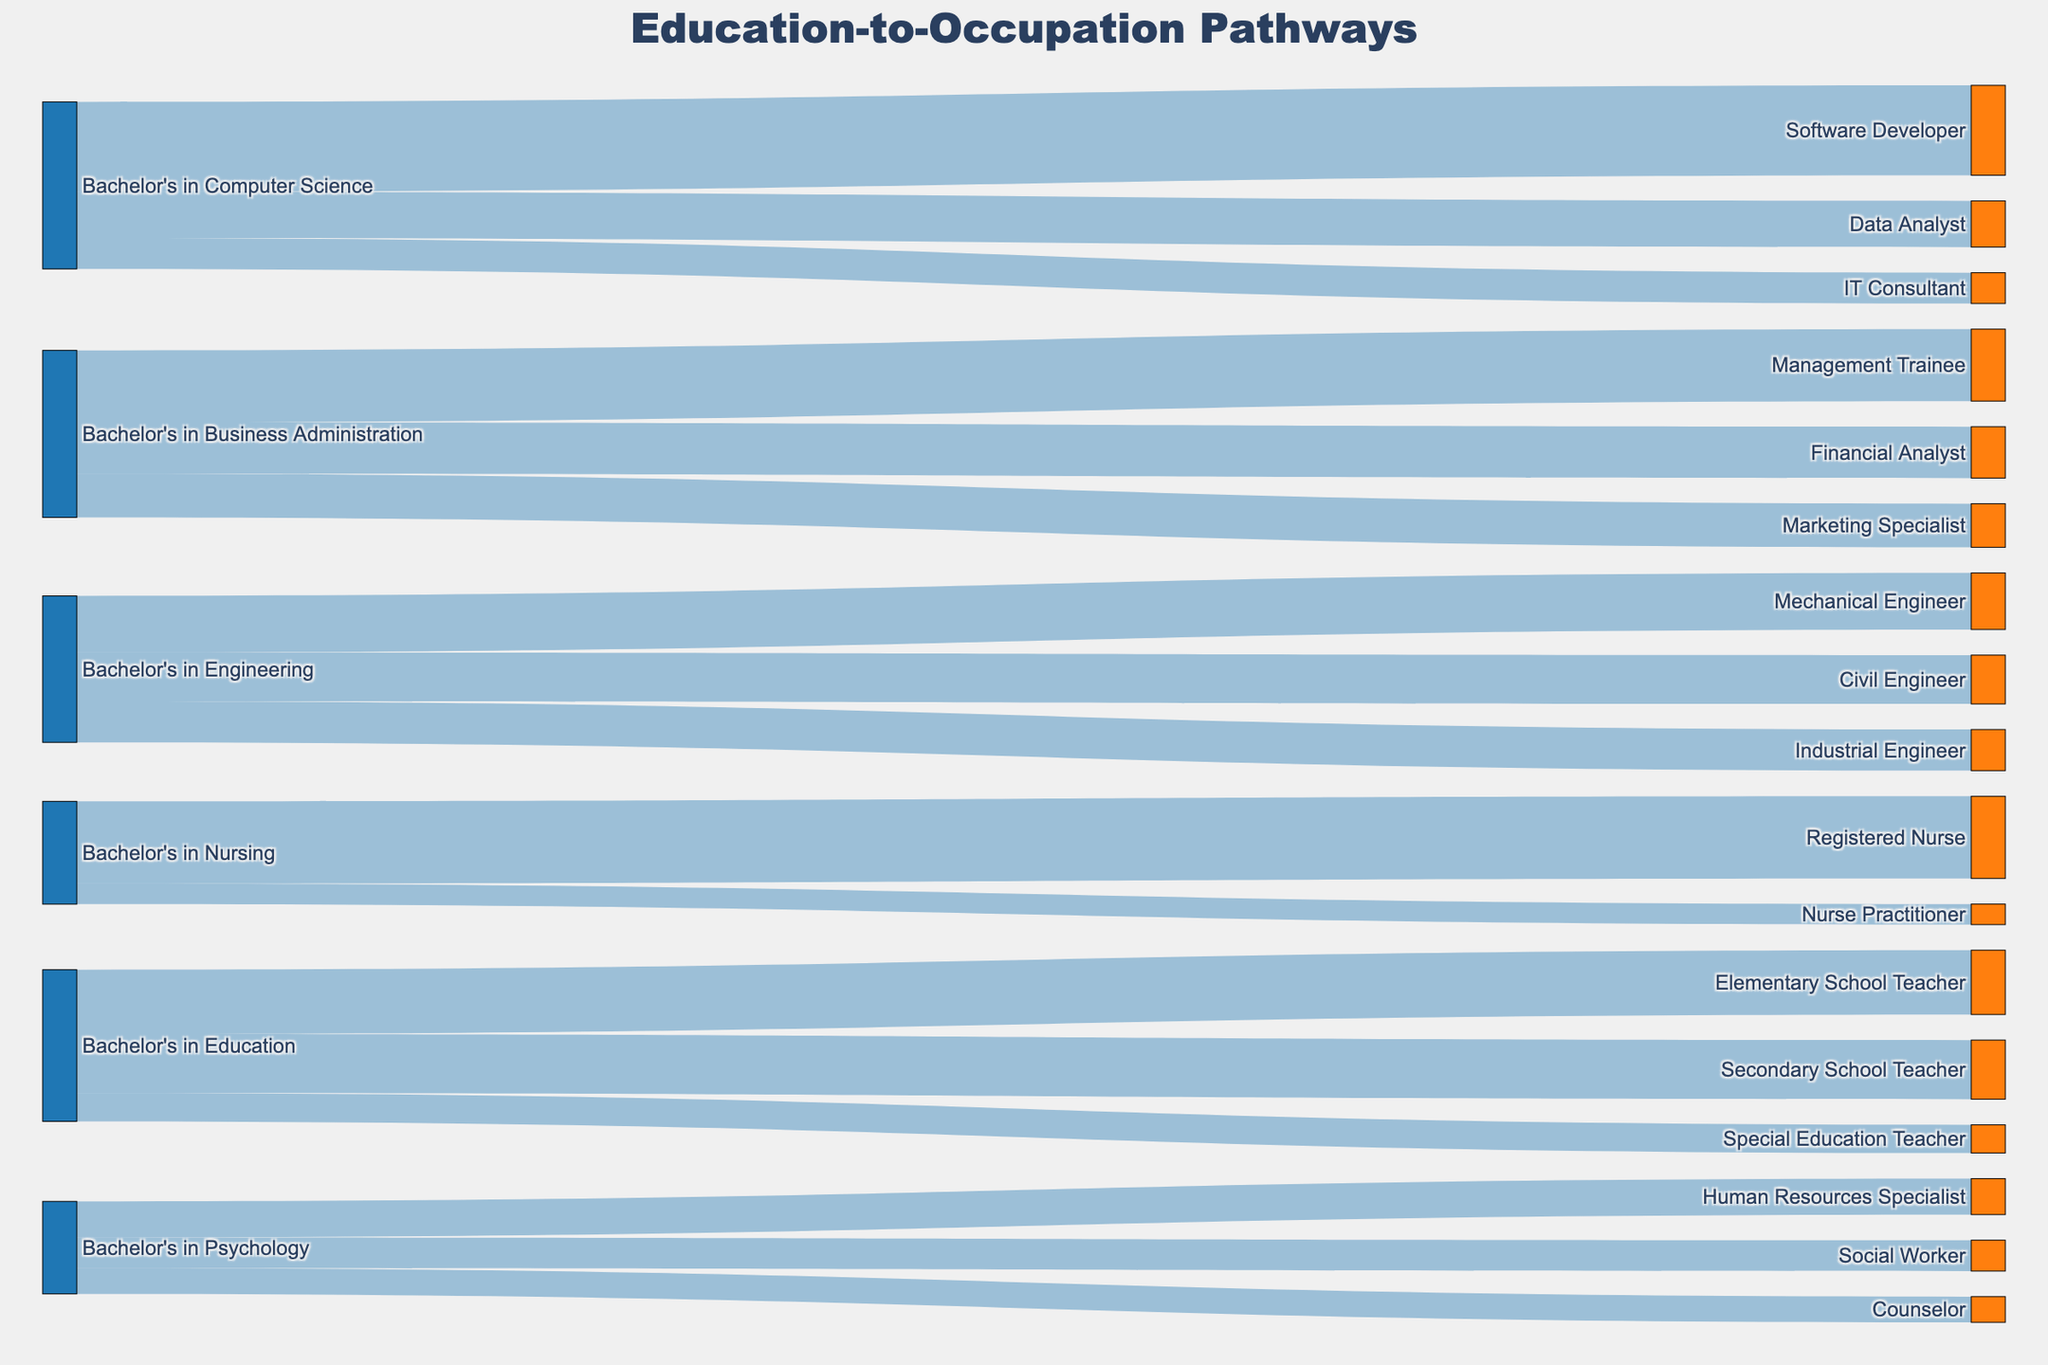What is the total number of paths leading from a Bachelor's in Computer Science to specific occupations? The figure shows three pathways from a Bachelor's in Computer Science to specific occupations: Software Developer, Data Analyst, and IT Consultant. Adding the number of people in these pathways, 3500 + 1800 + 1200 = 6500.
Answer: 6500 Which field of study has the highest number of graduates moving into a single occupation, and what is the occupation? The figure shows various fields of study leading to different occupations, with the number of graduates for each pathway. The pathway with the highest number of graduates is Bachelor's in Computer Science to Software Developer, with 3500 graduates.
Answer: Computer Science to Software Developer Compare the number of graduates becoming Registered Nurses with those becoming Software Developers. Which is higher and by how much? From the figure, we can see that there are 3200 graduates becoming Registered Nurses and 3500 becoming Software Developers. The difference is 3500 - 3200 = 300, so Software Developers are higher by 300 graduates.
Answer: Software Developers by 300 What is the total number of unique occupations listed across all fields of study? The figure lists several occupations resulting from different fields of study. Counting each unique occupation (Software Developer, Data Analyst, IT Consultant, Management Trainee, Financial Analyst, Marketing Specialist, Mechanical Engineer, Civil Engineer, Industrial Engineer, Registered Nurse, Nurse Practitioner, Elementary School Teacher, Secondary School Teacher, Special Education Teacher, Human Resources Specialist, Social Worker, Counselor), we get 17 unique occupations.
Answer: 17 Which has more graduates, those with a Bachelor's in Business Administration going into Financial Analysis or those with a Bachelor's in Engineering going into Civil Engineering? From the figure, we see that there are 2000 graduates going into Financial Analysis from Business Administration, and 1900 going into Civil Engineering from Engineering. 2000 is greater than 1900, so Financial Analysis has more graduates.
Answer: Financial Analysis What is the total number of graduates moving into education-related occupations? The figure shows the pathways from a Bachelor's in Education leading to Elementary School Teacher, Secondary School Teacher, and Special Education Teacher. Adding these pathways, 2500 + 2300 + 1100 = 5900 graduates.
Answer: 5900 How many more graduates are there in Nursing-related occupations compared to Psychology-related occupations? From the figure, there are 3200 Registered Nurses and 800 Nurse Practitioners, totaling 3200 + 800 = 4000 in Nursing. For Psychology, there are 1400 Human Resources Specialists, 1200 Social Workers, and 1000 Counselors, totaling 1400 + 1200 + 1000 = 3600. The difference is 4000 - 3600 = 400 more Nursing graduates.
Answer: 400 Which occupation has the lowest number of graduates and from which field of study? Looking at the figure, the occupation with the lowest number of graduates is Nurse Practitioner with 800 graduates coming from a Bachelor's in Nursing.
Answer: Nurse Practitioner How does the number of graduates entering Management Trainee positions compare to those entering Marketing Specialist positions? The figure shows 2800 graduates from Business Administration moving into Management Trainee positions and 1700 into Marketing Specialist positions. Comparing these, 2800 is greater than 1700.
Answer: Management Trainee has more If you combine the number of graduates in Engineering-related occupations, what is the total? For the Engineering-related occupations, we have Mechanical Engineer (2200), Civil Engineer (1900), and Industrial Engineer (1600). Adding these together, 2200 + 1900 + 1600 = 5700.
Answer: 5700 